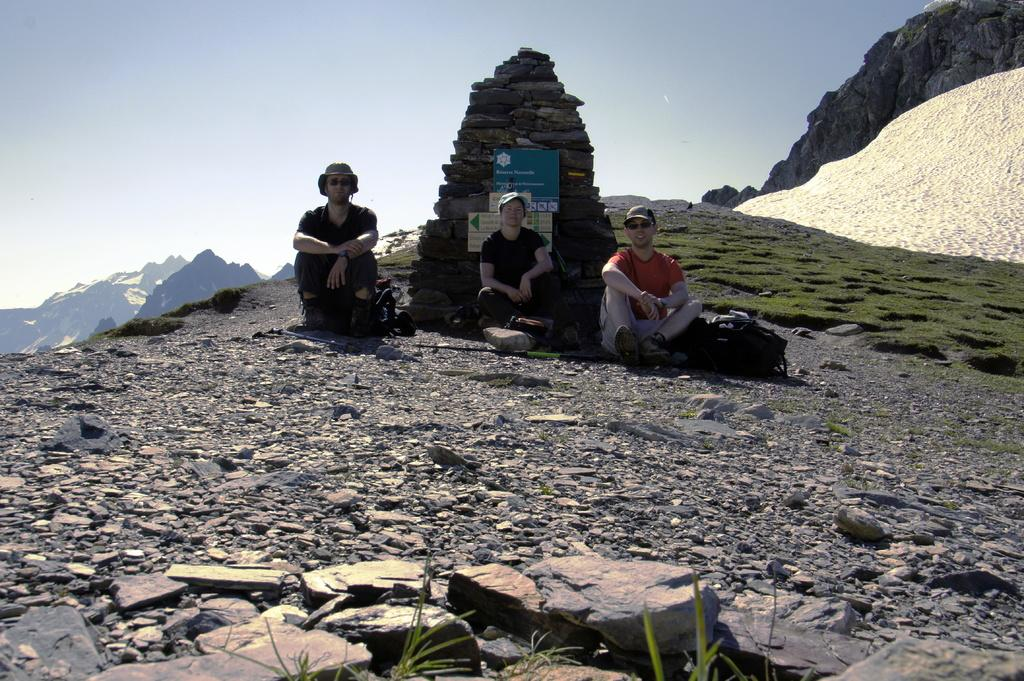How many people are sitting in the image? There are three persons sitting in the image. What is on the ground in some areas of the image? There is grass on the ground in some areas of the image. What geographical feature can be seen in the image? There is a mountain in the image. What is visible at the top of the image? The sky is visible at the top of the image. What is the condition of the sky in the image? The sky is cloudy in the image. How much impulse does the print on the mountain have in the image? There is no print on the mountain in the image, so it is not possible to determine the impulse. 